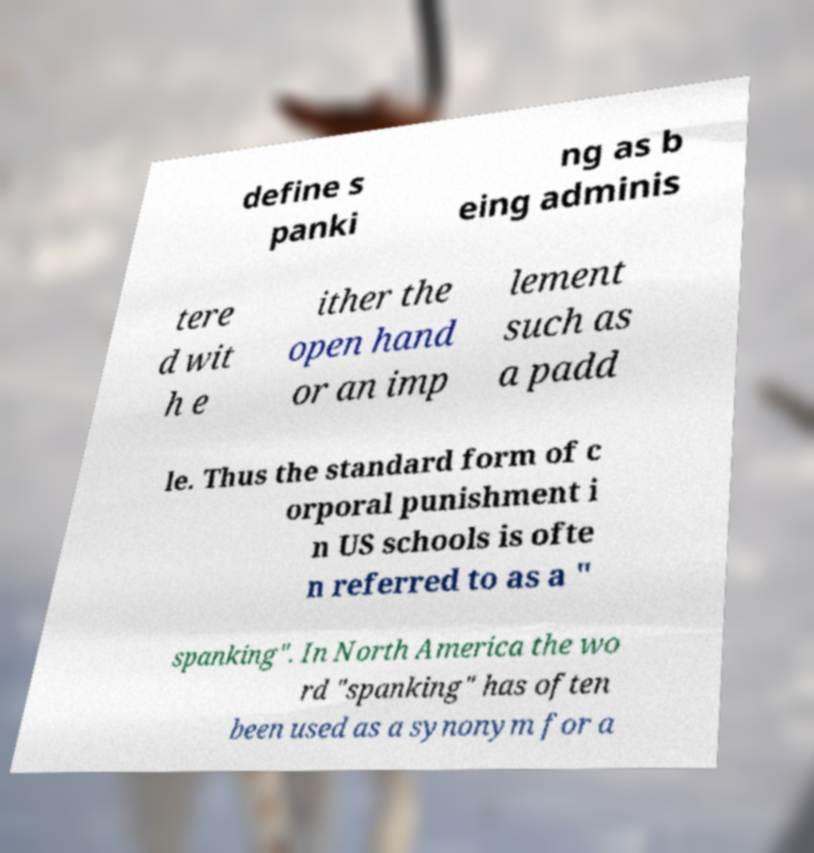There's text embedded in this image that I need extracted. Can you transcribe it verbatim? define s panki ng as b eing adminis tere d wit h e ither the open hand or an imp lement such as a padd le. Thus the standard form of c orporal punishment i n US schools is ofte n referred to as a " spanking". In North America the wo rd "spanking" has often been used as a synonym for a 